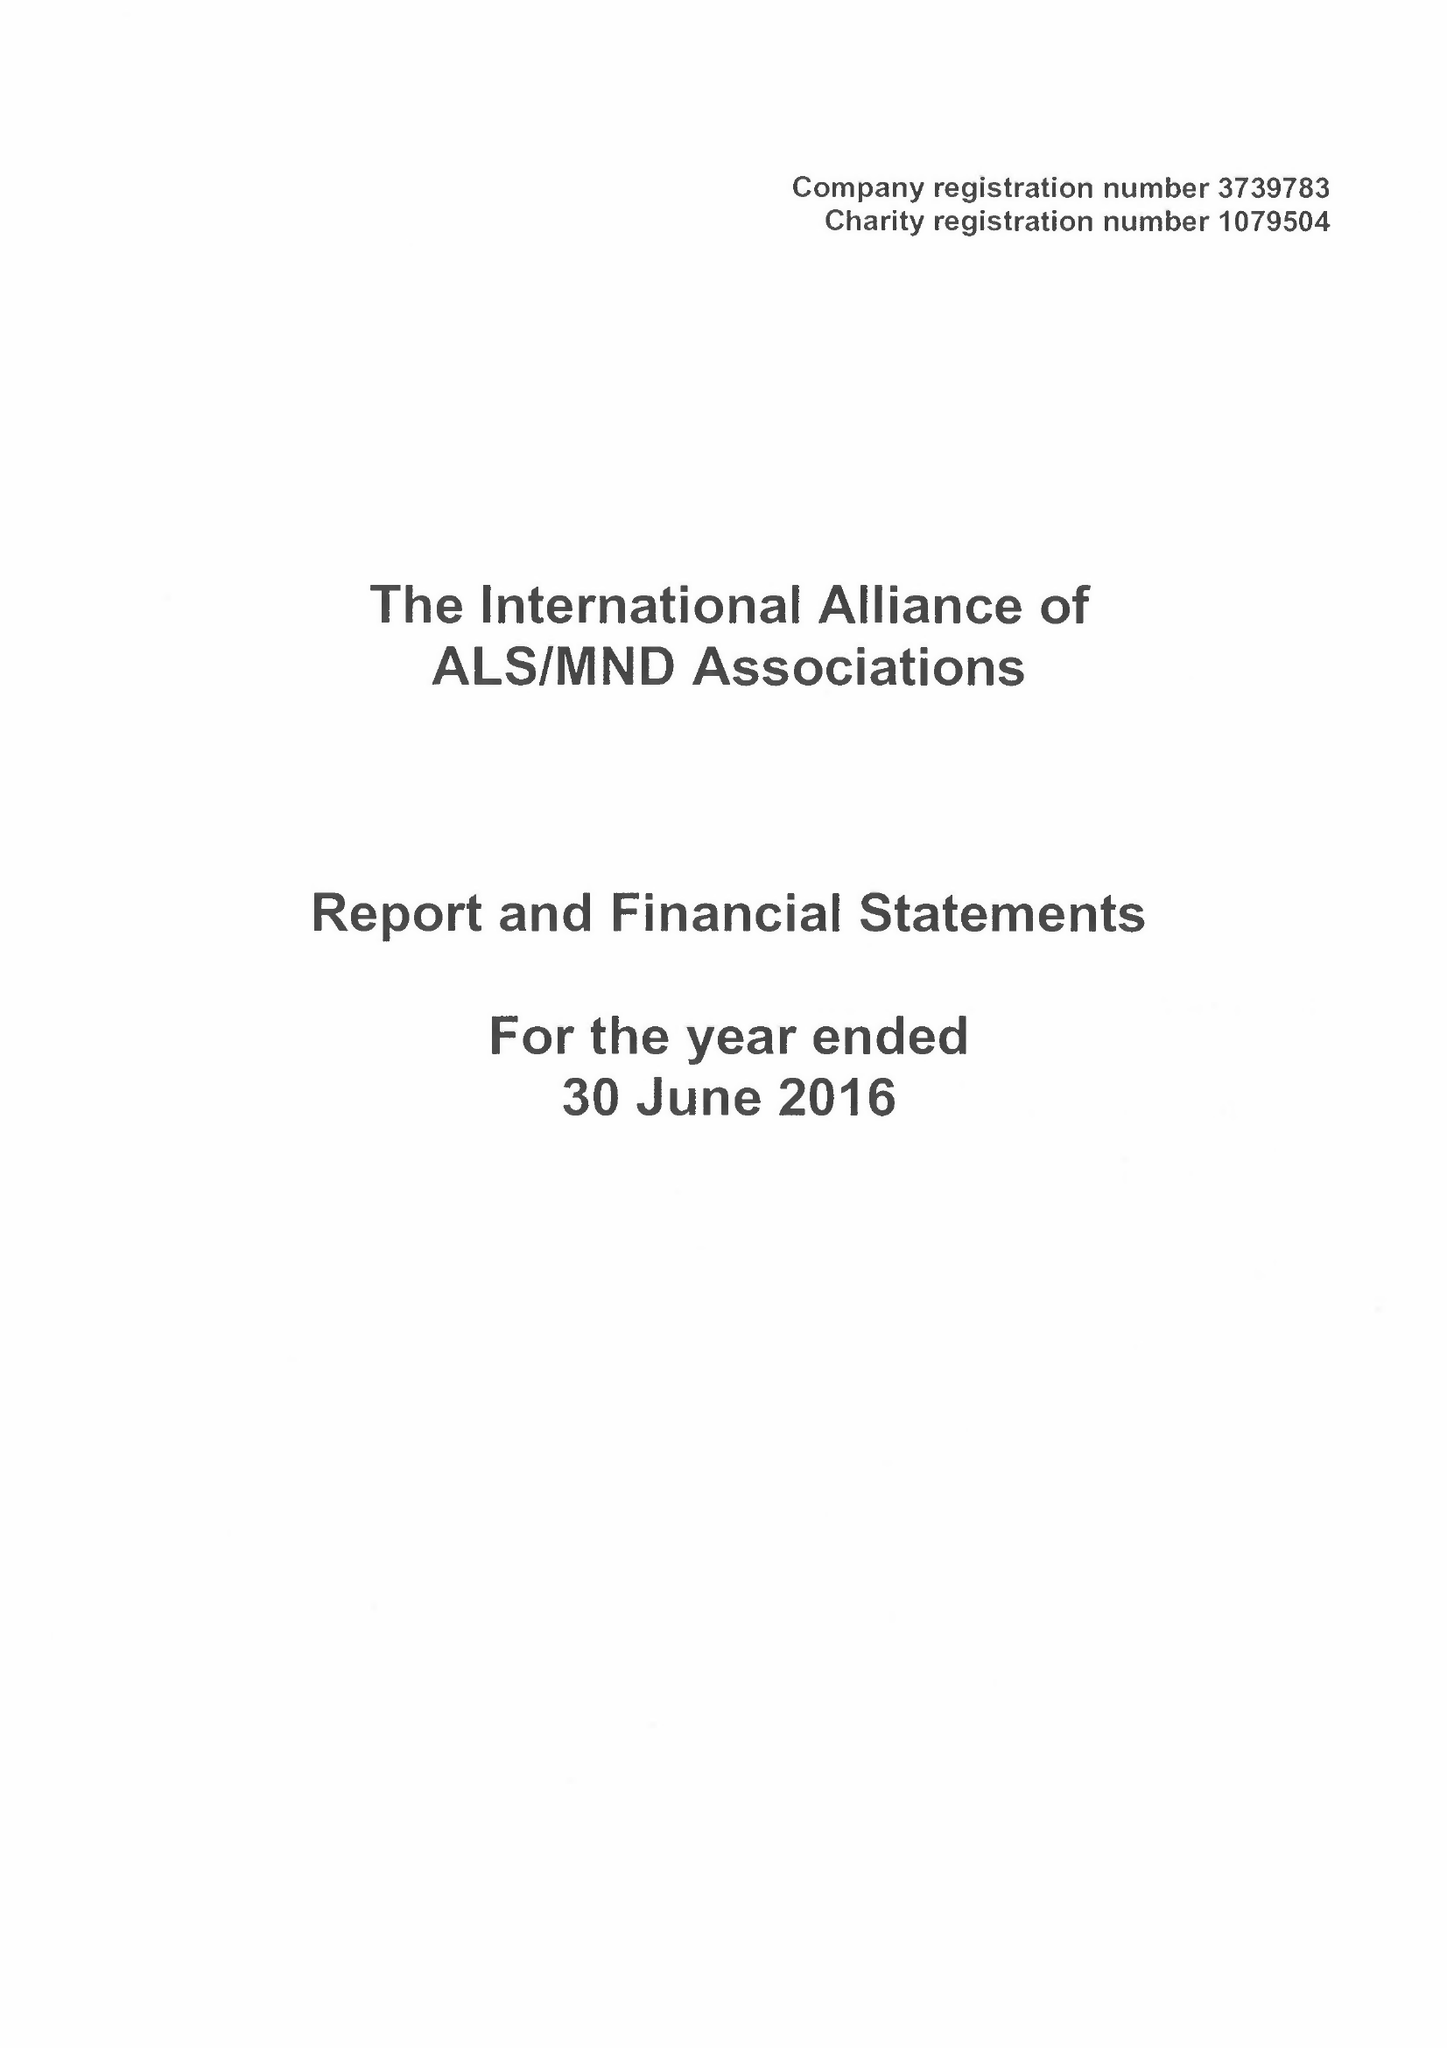What is the value for the address__post_town?
Answer the question using a single word or phrase. NORTHAMPTON 